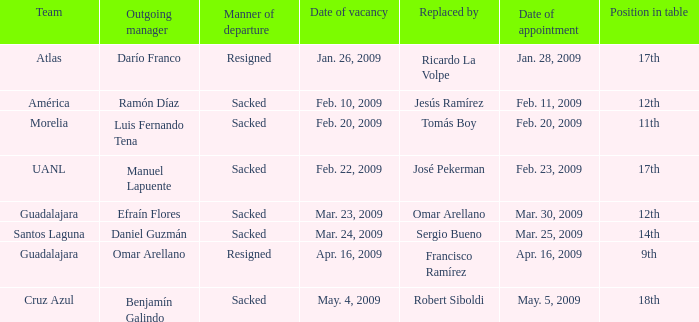What is Team, when Replaced By is "Omar Arellano"? Guadalajara. 